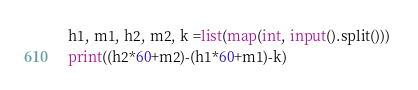<code> <loc_0><loc_0><loc_500><loc_500><_Python_>h1, m1, h2, m2, k =list(map(int, input().split())) 
print((h2*60+m2)-(h1*60+m1)-k)</code> 